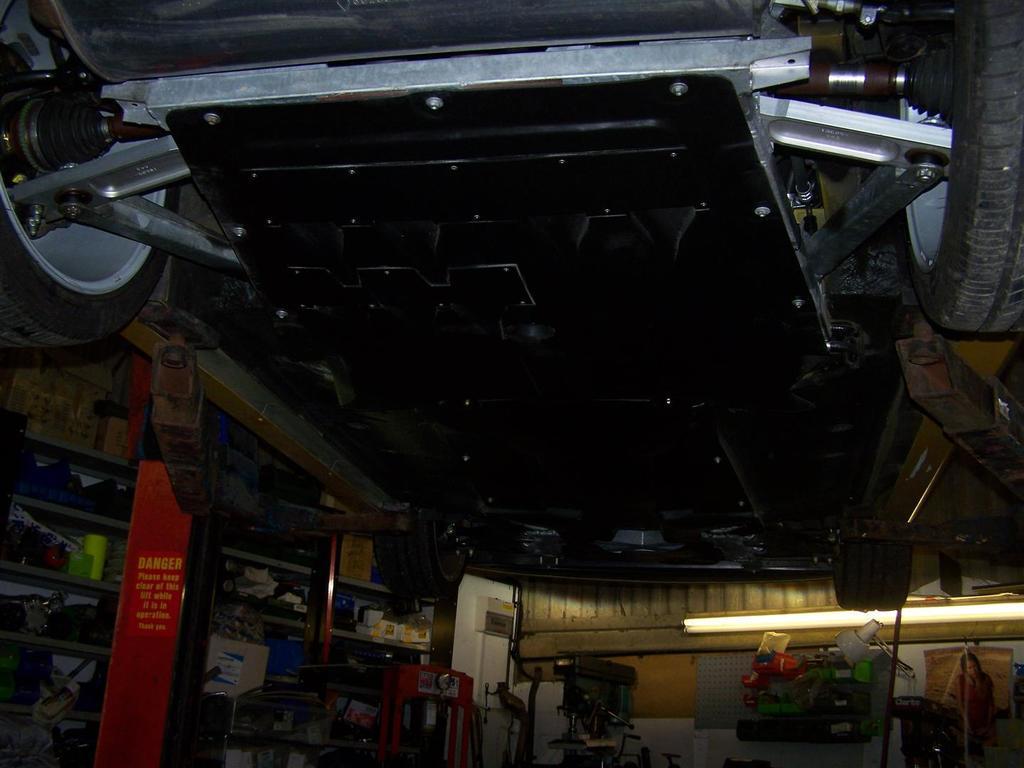Can you describe this image briefly? In this image in front there is a car. On the left side of the image there are a few objects on the rack. In the background of the image there is a tube light and there are a few objects. 